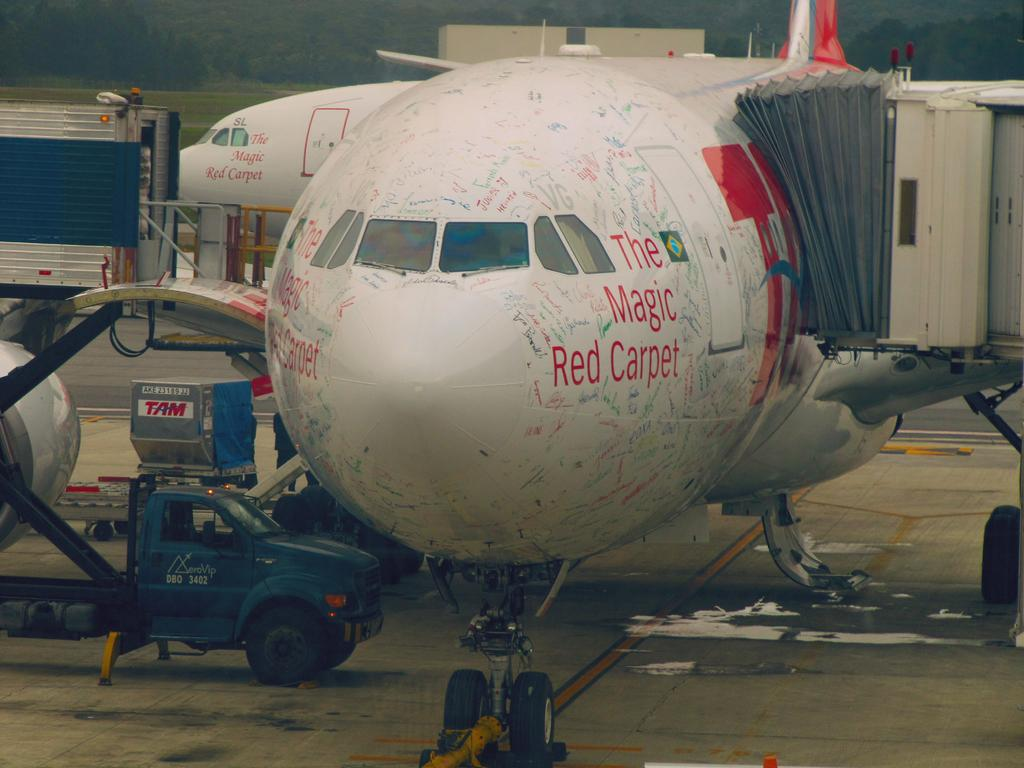<image>
Provide a brief description of the given image. "The Magic Red Carpet" is displayed on the side of a docked plane. 